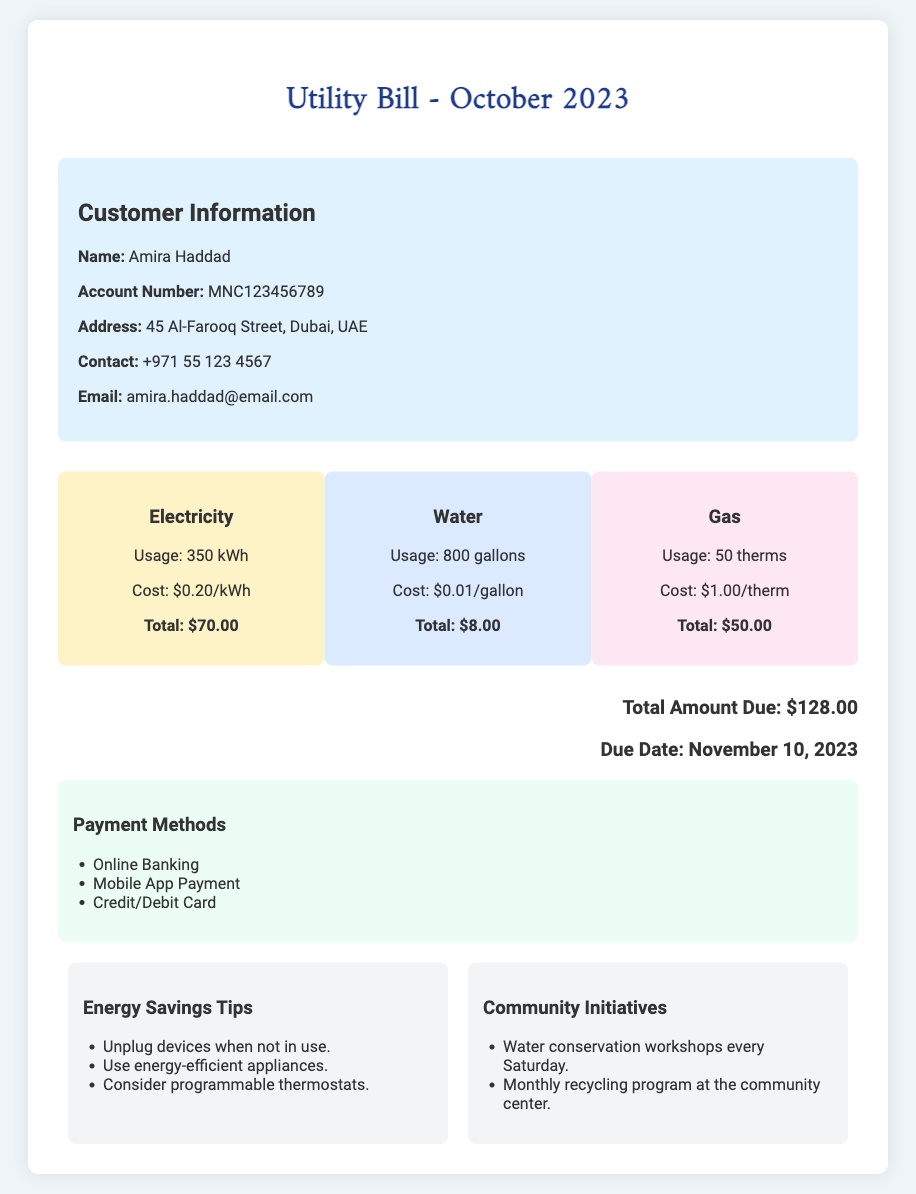What is the name of the customer? The document provides the customer's name in the customer information section, which is Amira Haddad.
Answer: Amira Haddad What is the account number? The account number is listed directly under the customer's name in the document.
Answer: MNC123456789 What is the total amount due? The total amount due is stated at the bottom of the document as the total charges for the month.
Answer: $128.00 How much was charged for electricity? The charge for electricity is specified under the electricity section, detailing the cost and usage.
Answer: $70.00 What is the usage for water? The water usage is mentioned in gallons in the water section of the document.
Answer: 800 gallons When is the due date for payment? The due date is mentioned in the total amount due section of the document.
Answer: November 10, 2023 What payment methods are available? The document lists different payment methods available for settling the bill.
Answer: Online Banking, Mobile App Payment, Credit/Debit Card What is the usage for gas? The document specifies the amount of gas usage in therms.
Answer: 50 therms What is the cost per gallon of water? The cost per gallon for water is detailed in the water section of the document.
Answer: $0.01/gallon 